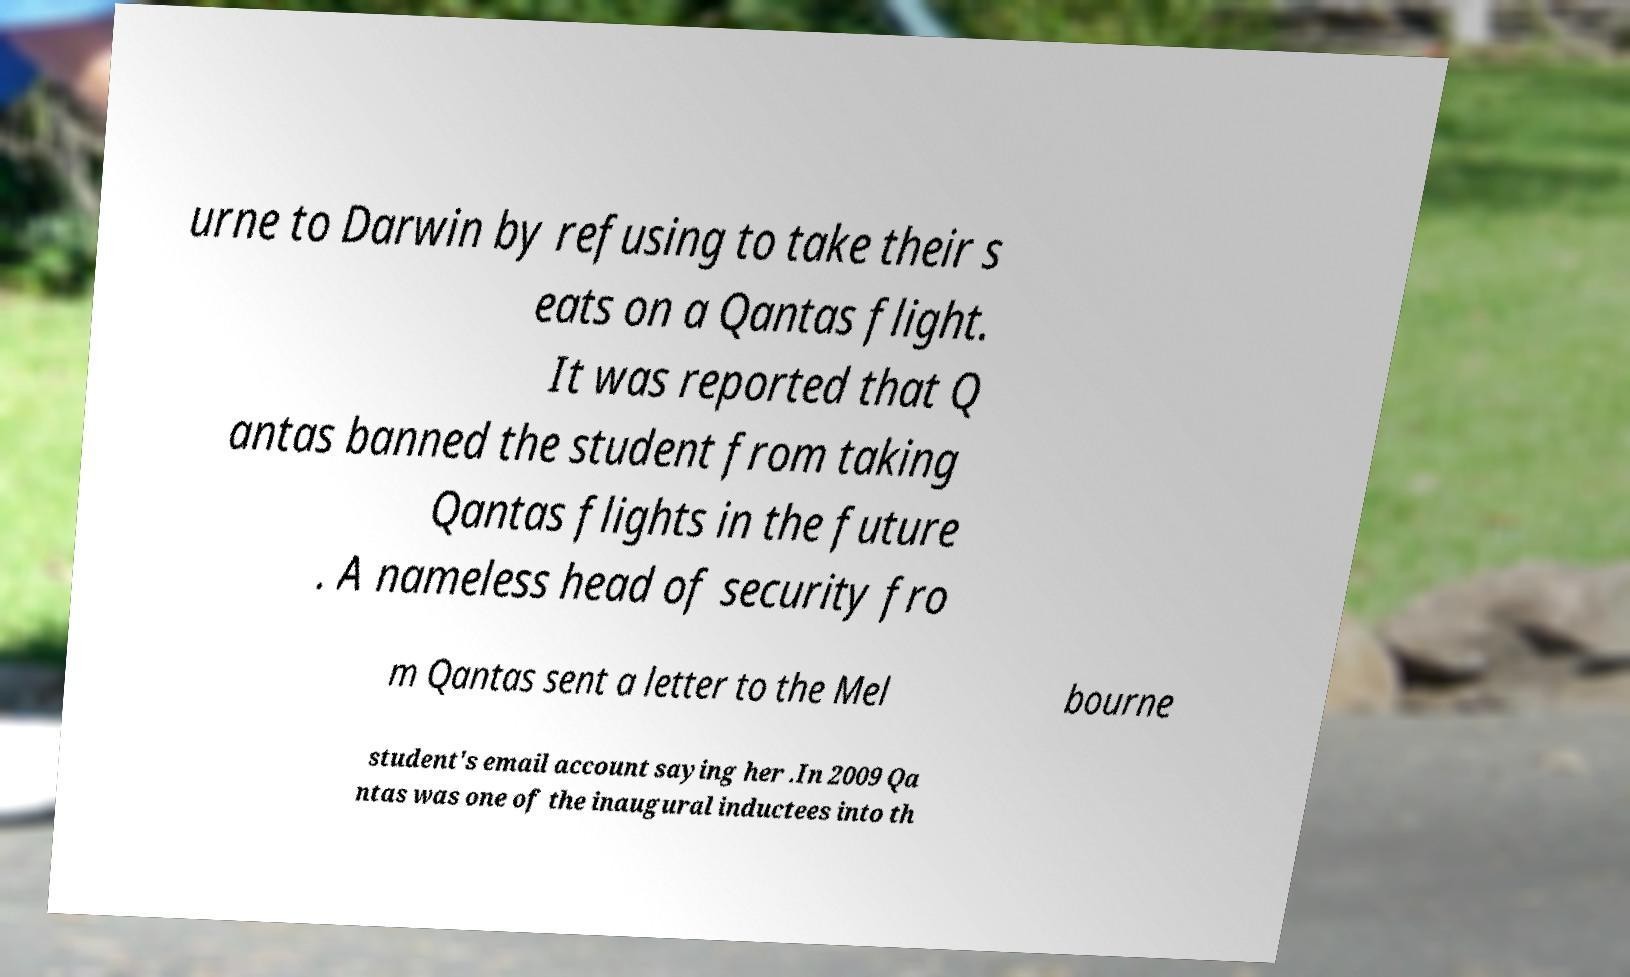Please identify and transcribe the text found in this image. urne to Darwin by refusing to take their s eats on a Qantas flight. It was reported that Q antas banned the student from taking Qantas flights in the future . A nameless head of security fro m Qantas sent a letter to the Mel bourne student's email account saying her .In 2009 Qa ntas was one of the inaugural inductees into th 